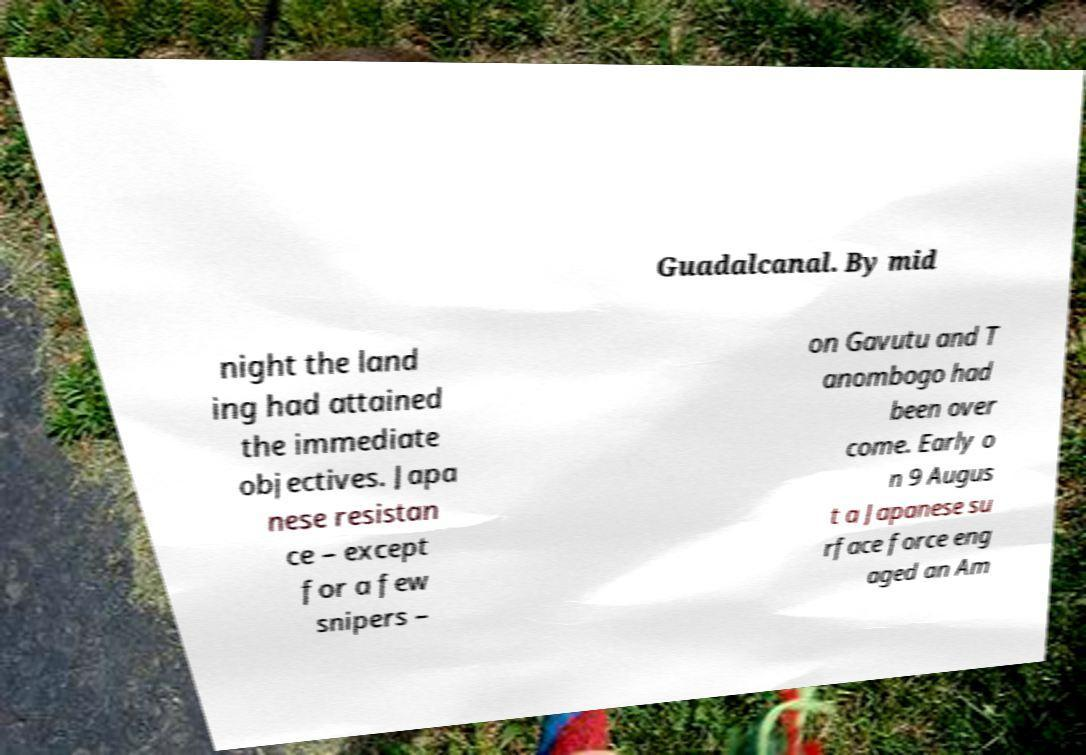Please read and relay the text visible in this image. What does it say? Guadalcanal. By mid night the land ing had attained the immediate objectives. Japa nese resistan ce – except for a few snipers – on Gavutu and T anombogo had been over come. Early o n 9 Augus t a Japanese su rface force eng aged an Am 